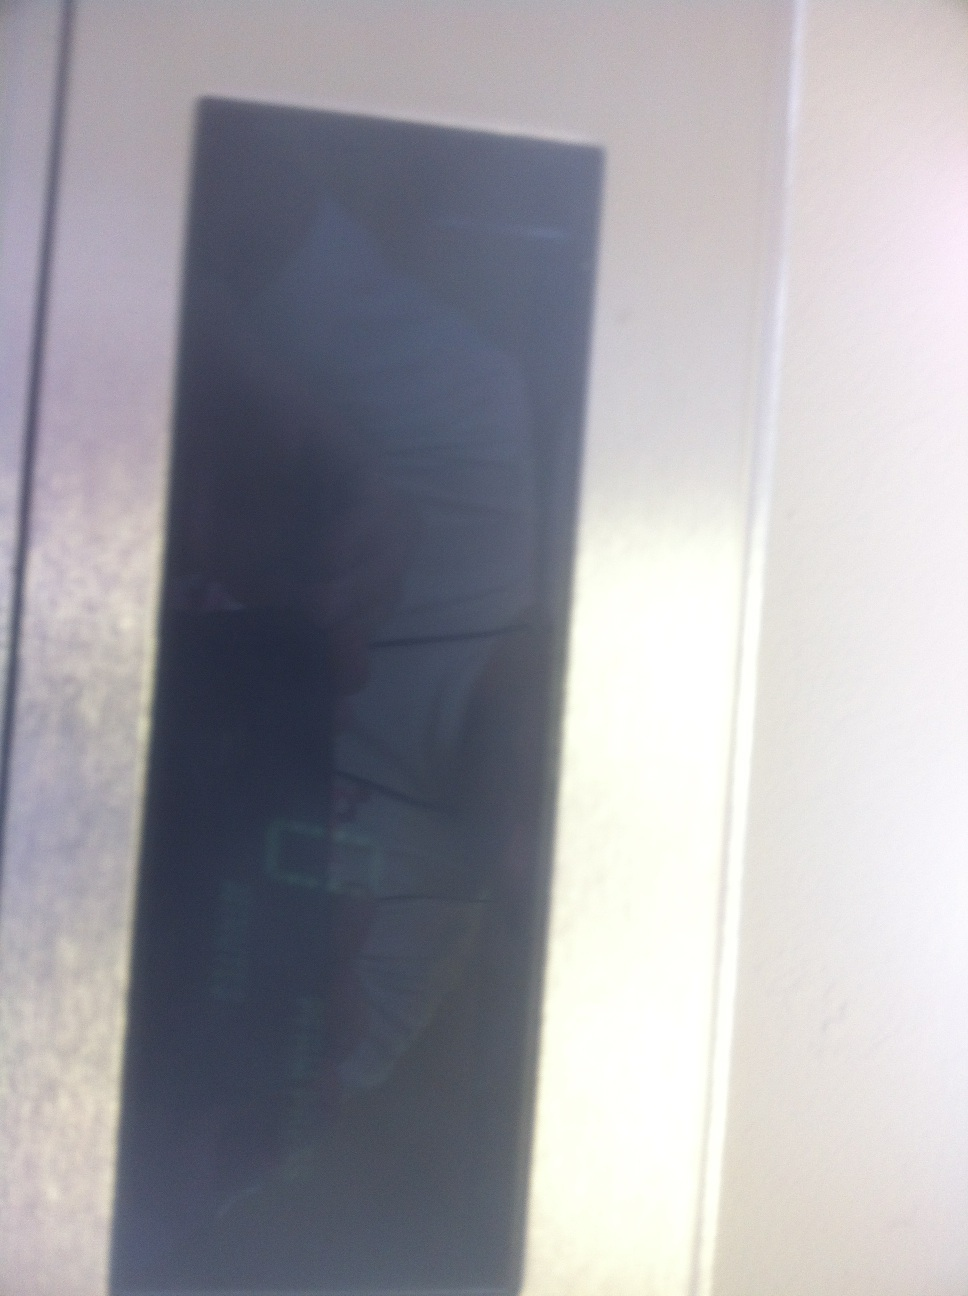What kind of maintenance might this display require? Displays like this often require routine cleaning to remove fingerprints and dust that may obscure visibility. Additionally, regular checks to ensure all digital elements are functioning correctly and that there are no pixel issues or malfunctions might be necessary. Depending on its use, software updates might also be required to ensure it operates with the latest features and security protocols. 